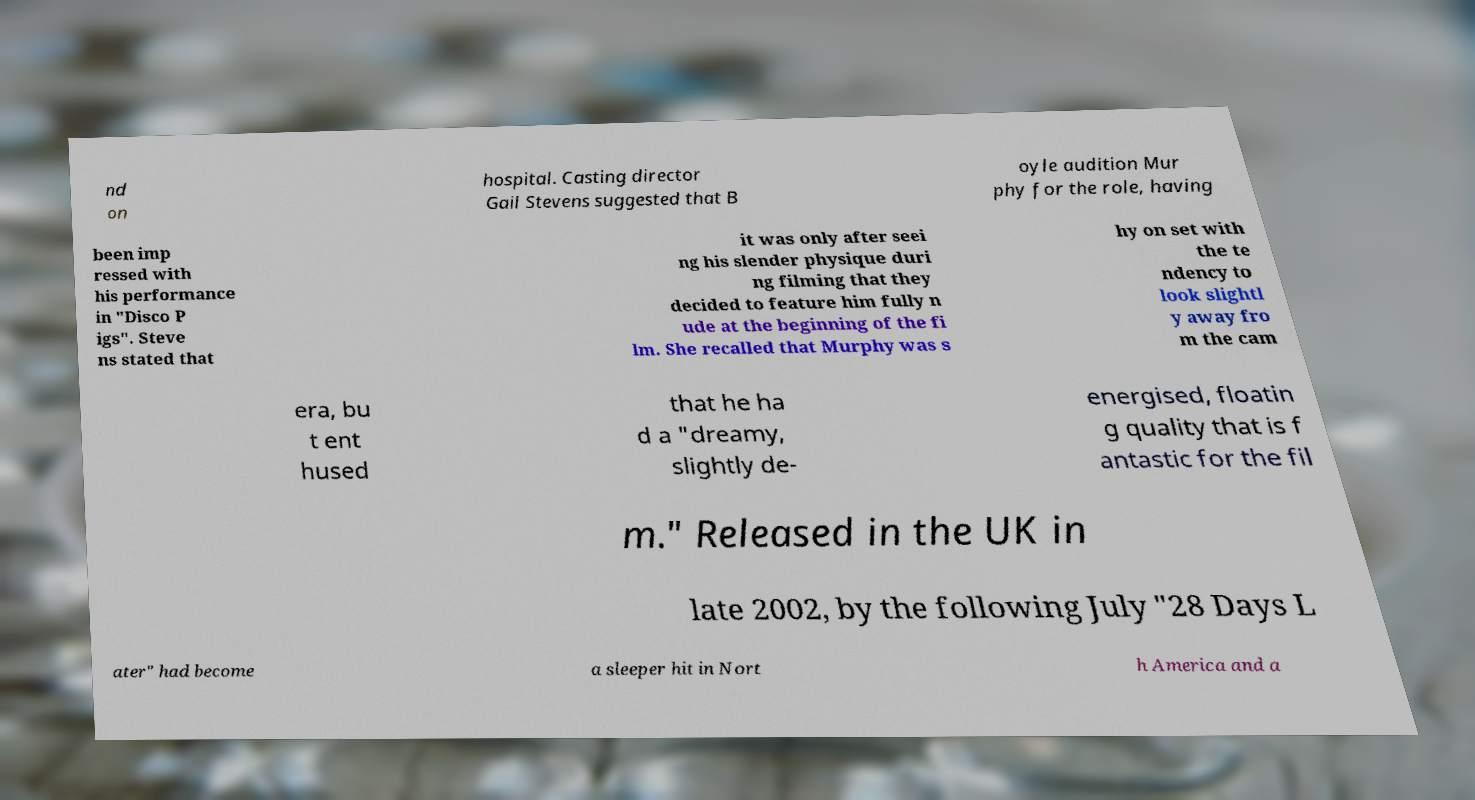There's text embedded in this image that I need extracted. Can you transcribe it verbatim? nd on hospital. Casting director Gail Stevens suggested that B oyle audition Mur phy for the role, having been imp ressed with his performance in "Disco P igs". Steve ns stated that it was only after seei ng his slender physique duri ng filming that they decided to feature him fully n ude at the beginning of the fi lm. She recalled that Murphy was s hy on set with the te ndency to look slightl y away fro m the cam era, bu t ent hused that he ha d a "dreamy, slightly de- energised, floatin g quality that is f antastic for the fil m." Released in the UK in late 2002, by the following July "28 Days L ater" had become a sleeper hit in Nort h America and a 